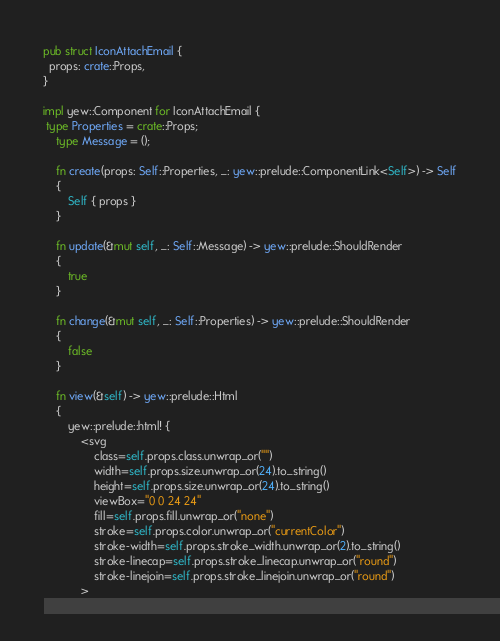Convert code to text. <code><loc_0><loc_0><loc_500><loc_500><_Rust_>
pub struct IconAttachEmail {
  props: crate::Props,
}

impl yew::Component for IconAttachEmail {
 type Properties = crate::Props;
    type Message = ();

    fn create(props: Self::Properties, _: yew::prelude::ComponentLink<Self>) -> Self
    {
        Self { props }
    }

    fn update(&mut self, _: Self::Message) -> yew::prelude::ShouldRender
    {
        true
    }

    fn change(&mut self, _: Self::Properties) -> yew::prelude::ShouldRender
    {
        false
    }

    fn view(&self) -> yew::prelude::Html
    {
        yew::prelude::html! {
            <svg
                class=self.props.class.unwrap_or("")
                width=self.props.size.unwrap_or(24).to_string()
                height=self.props.size.unwrap_or(24).to_string()
                viewBox="0 0 24 24"
                fill=self.props.fill.unwrap_or("none")
                stroke=self.props.color.unwrap_or("currentColor")
                stroke-width=self.props.stroke_width.unwrap_or(2).to_string()
                stroke-linecap=self.props.stroke_linecap.unwrap_or("round")
                stroke-linejoin=self.props.stroke_linejoin.unwrap_or("round")
            ></code> 